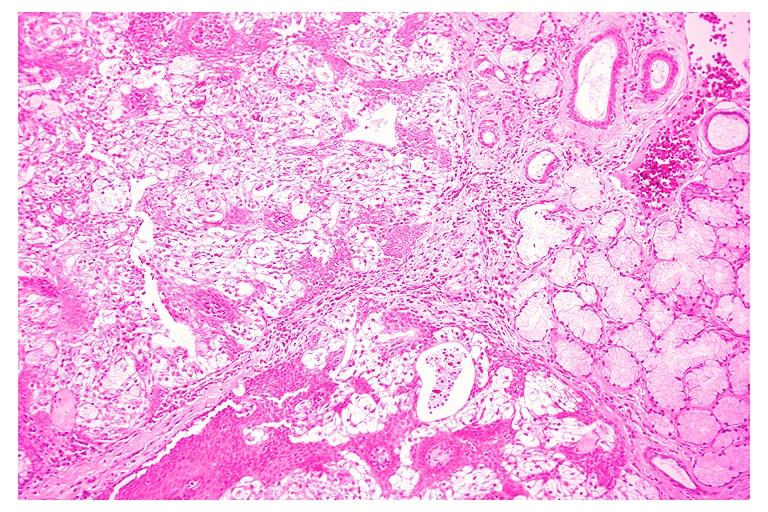what is present?
Answer the question using a single word or phrase. Oral 